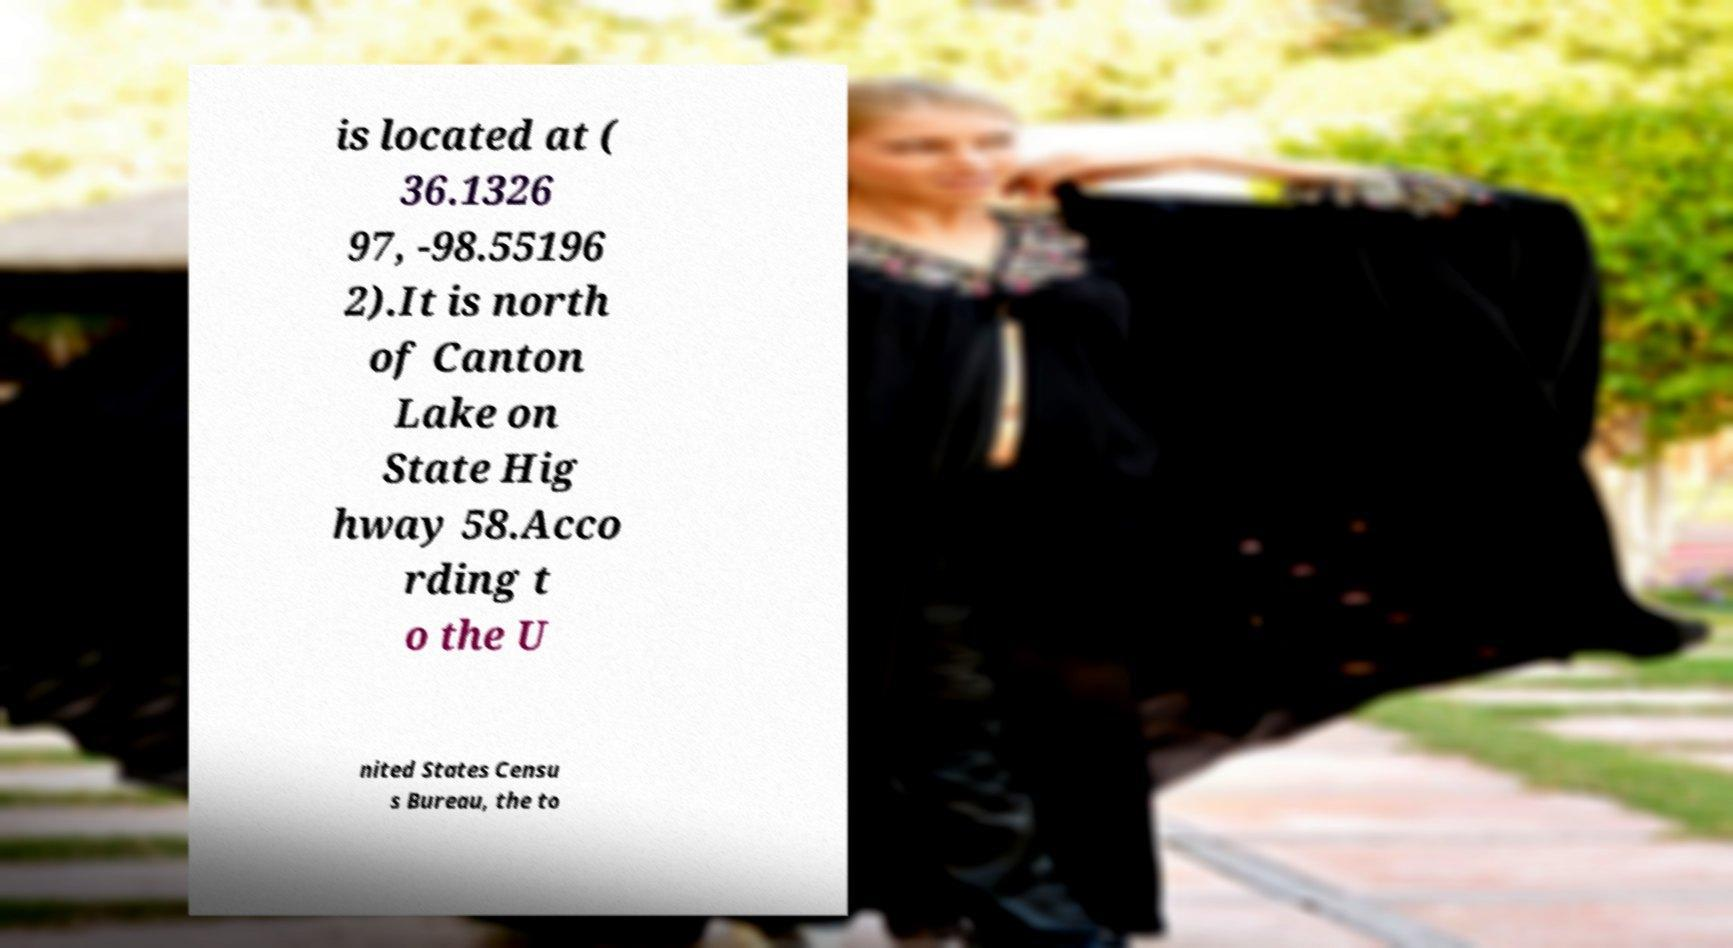Can you read and provide the text displayed in the image?This photo seems to have some interesting text. Can you extract and type it out for me? is located at ( 36.1326 97, -98.55196 2).It is north of Canton Lake on State Hig hway 58.Acco rding t o the U nited States Censu s Bureau, the to 